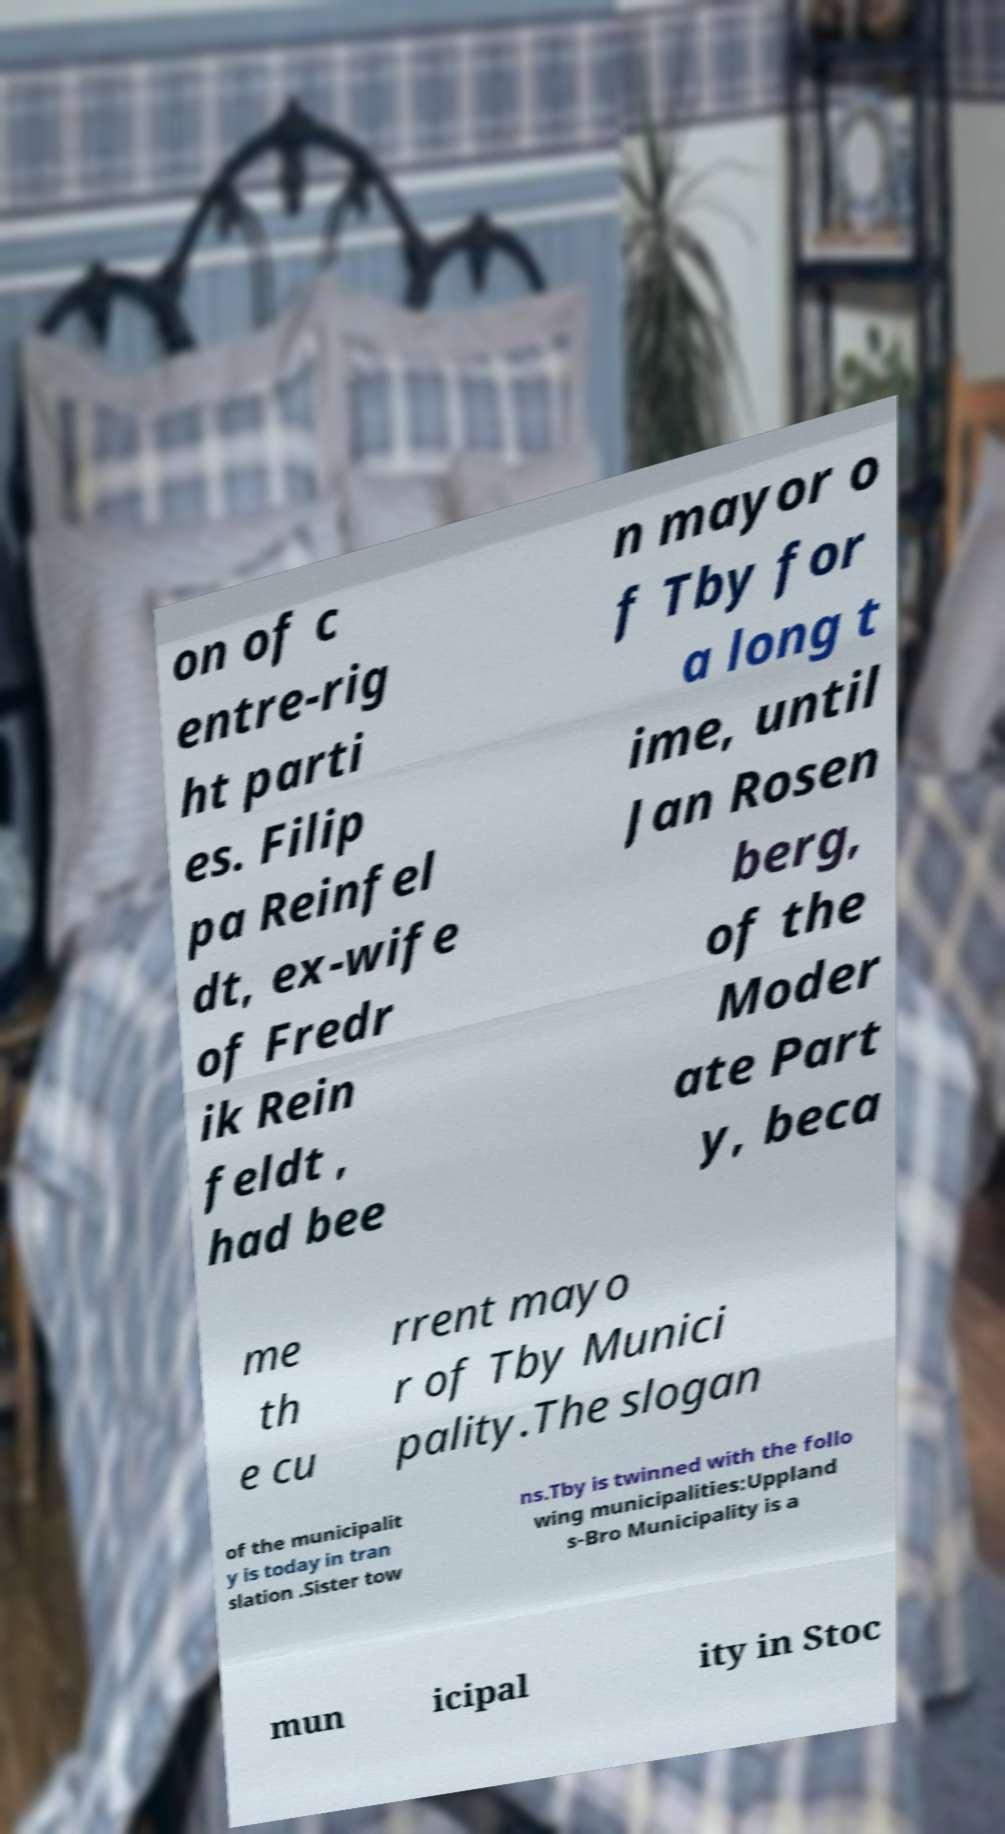Please identify and transcribe the text found in this image. on of c entre-rig ht parti es. Filip pa Reinfel dt, ex-wife of Fredr ik Rein feldt , had bee n mayor o f Tby for a long t ime, until Jan Rosen berg, of the Moder ate Part y, beca me th e cu rrent mayo r of Tby Munici pality.The slogan of the municipalit y is today in tran slation .Sister tow ns.Tby is twinned with the follo wing municipalities:Uppland s-Bro Municipality is a mun icipal ity in Stoc 